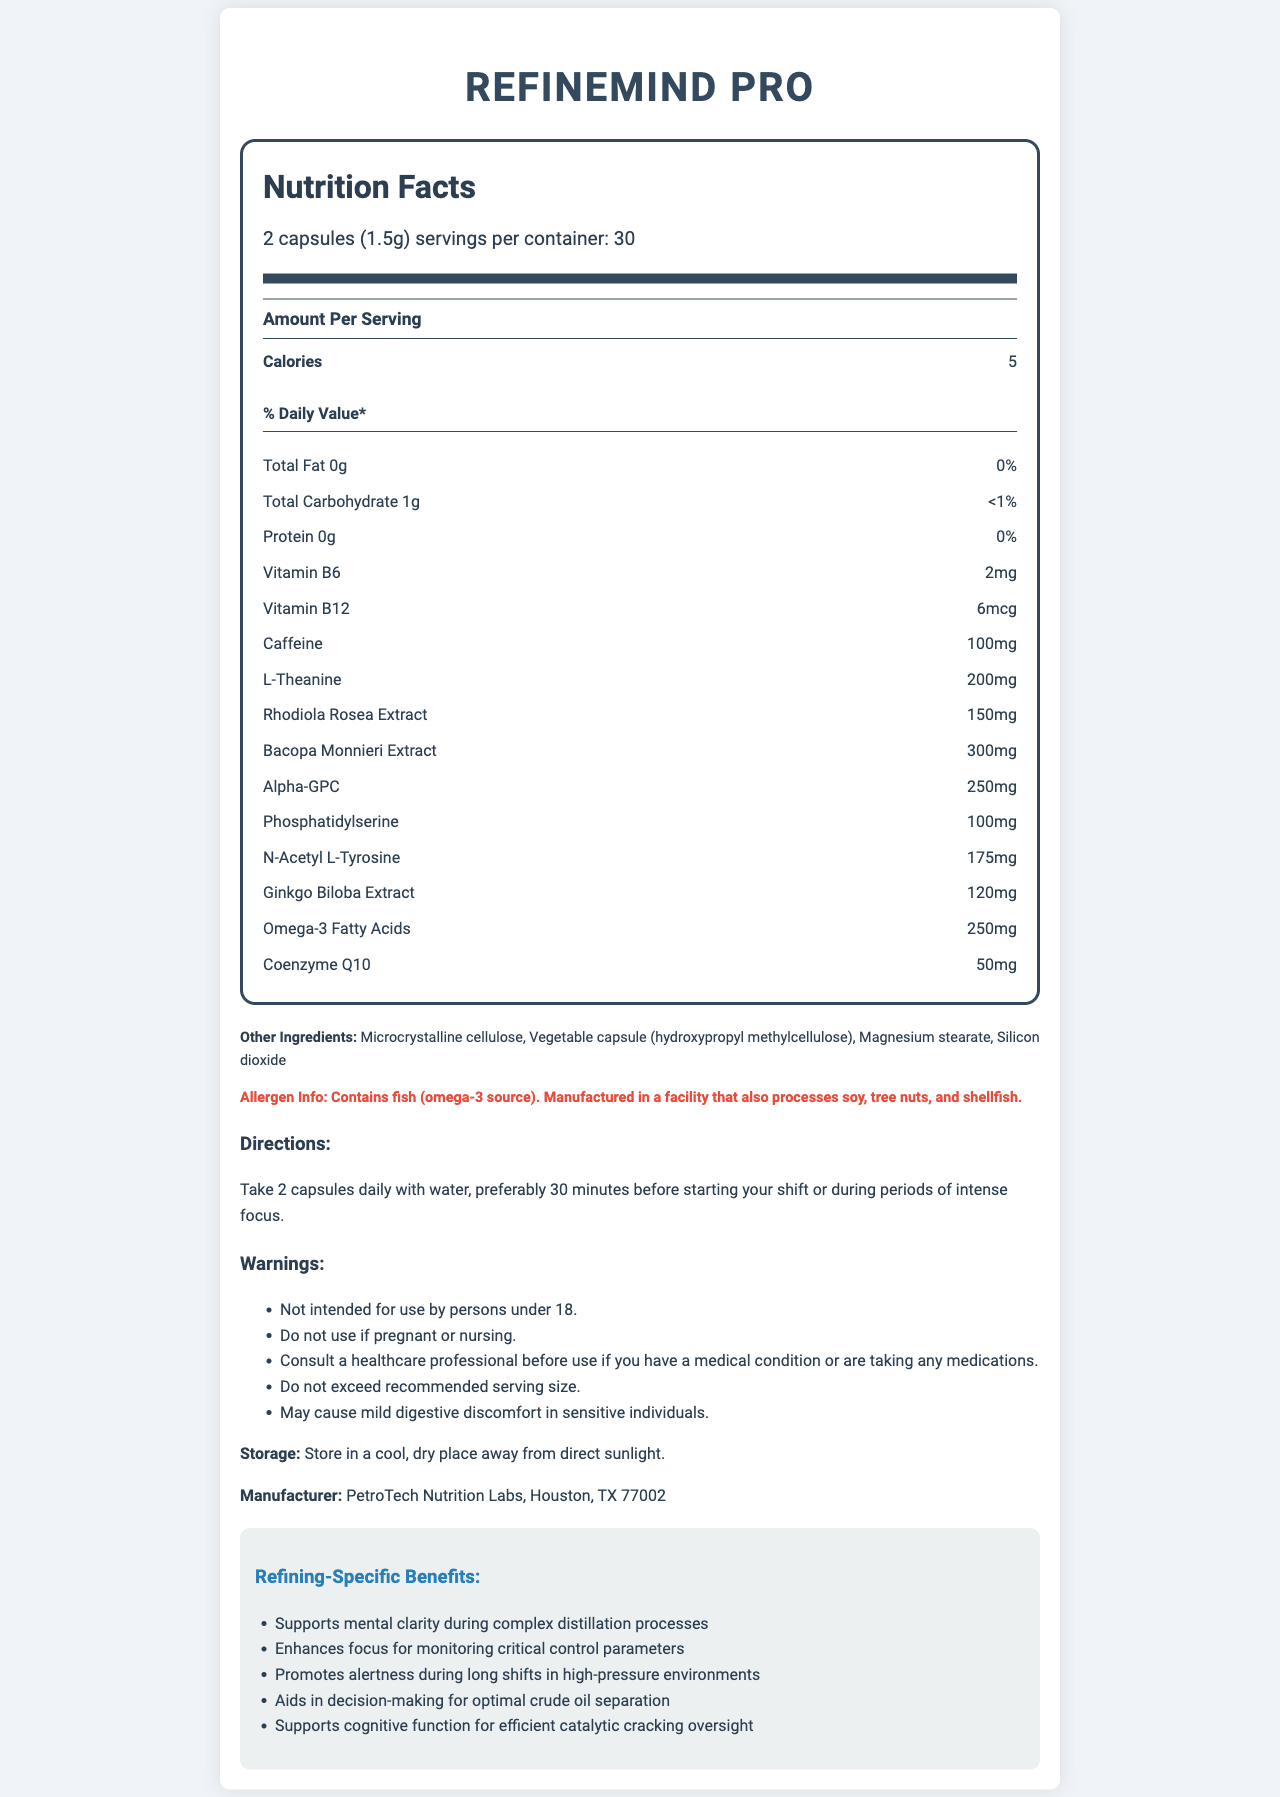What is the product name? The product name is clearly mentioned at the top of the document.
Answer: RefineMind Pro What is the serving size of RefineMind Pro? The serving size is stated in the serving information section under the nutrition label.
Answer: 2 capsules (1.5g) How many servings are there per container? It is indicated in the serving information section.
Answer: 30 servings How many calories are in each serving? The calorie content per serving is listed under the "Amount Per Serving" section.
Answer: 5 calories List three key ingredients found in RefineMind Pro. These ingredients are mentioned individually under the nutrition label.
Answer: Caffeine, L-Theanine, Bacopa Monnieri Extract What is the amount of Vitamin B6 in each serving? The amount of Vitamin B6 is specified under the nutrients in the nutrition label.
Answer: 2mg Does RefineMind Pro contain any allergens? This information is provided in the allergen info section.
Answer: Yes, it contains fish. When should RefineMind Pro be taken? A. With meals B. 30 minutes before starting your shift C. During periods of rest D. After workouts According to the directions, it is recommended to take 2 capsules daily, preferably 30 minutes before starting your shift or during periods of intense focus.
Answer: B Which of the following is NOT an ingredient in RefineMind Pro? A. Coenzyme Q10 B. Magnesium stearate C. Soy D. Rhodiola Rosea Extract The document indicates that the product contains Coenzyme Q10, Magnesium stearate, and Rhodiola Rosea Extract but is manufactured in a facility that processes soy; it does not list soy as a direct ingredient.
Answer: C Is RefineMind Pro intended for use by children? The warnings state that it is not intended for use by persons under 18.
Answer: No Summarize the main benefits of RefineMind Pro for refining processes. These benefits are listed under the refining-specific benefits section.
Answer: Supports mental clarity, enhances focus, promotes alertness, aids in decision-making, and supports cognitive function What is the exact address of the manufacturer? The document only specifies "Houston, TX 77002" but does not provide an exact street address.
Answer: Cannot be determined What type of capsule is used for RefineMind Pro? This information is listed under other ingredients.
Answer: Vegetable capsule (hydroxypropyl methylcellulose) What should be done if the recommended serving size is exceeded? Although it advises not to exceed the recommended serving size, the warning section implies consulting a healthcare professional for any concerns.
Answer: Consult a healthcare professional Describe any potential side effects mentioned. This potential side effect is listed under the warnings section.
Answer: May cause mild digestive discomfort in sensitive individuals 